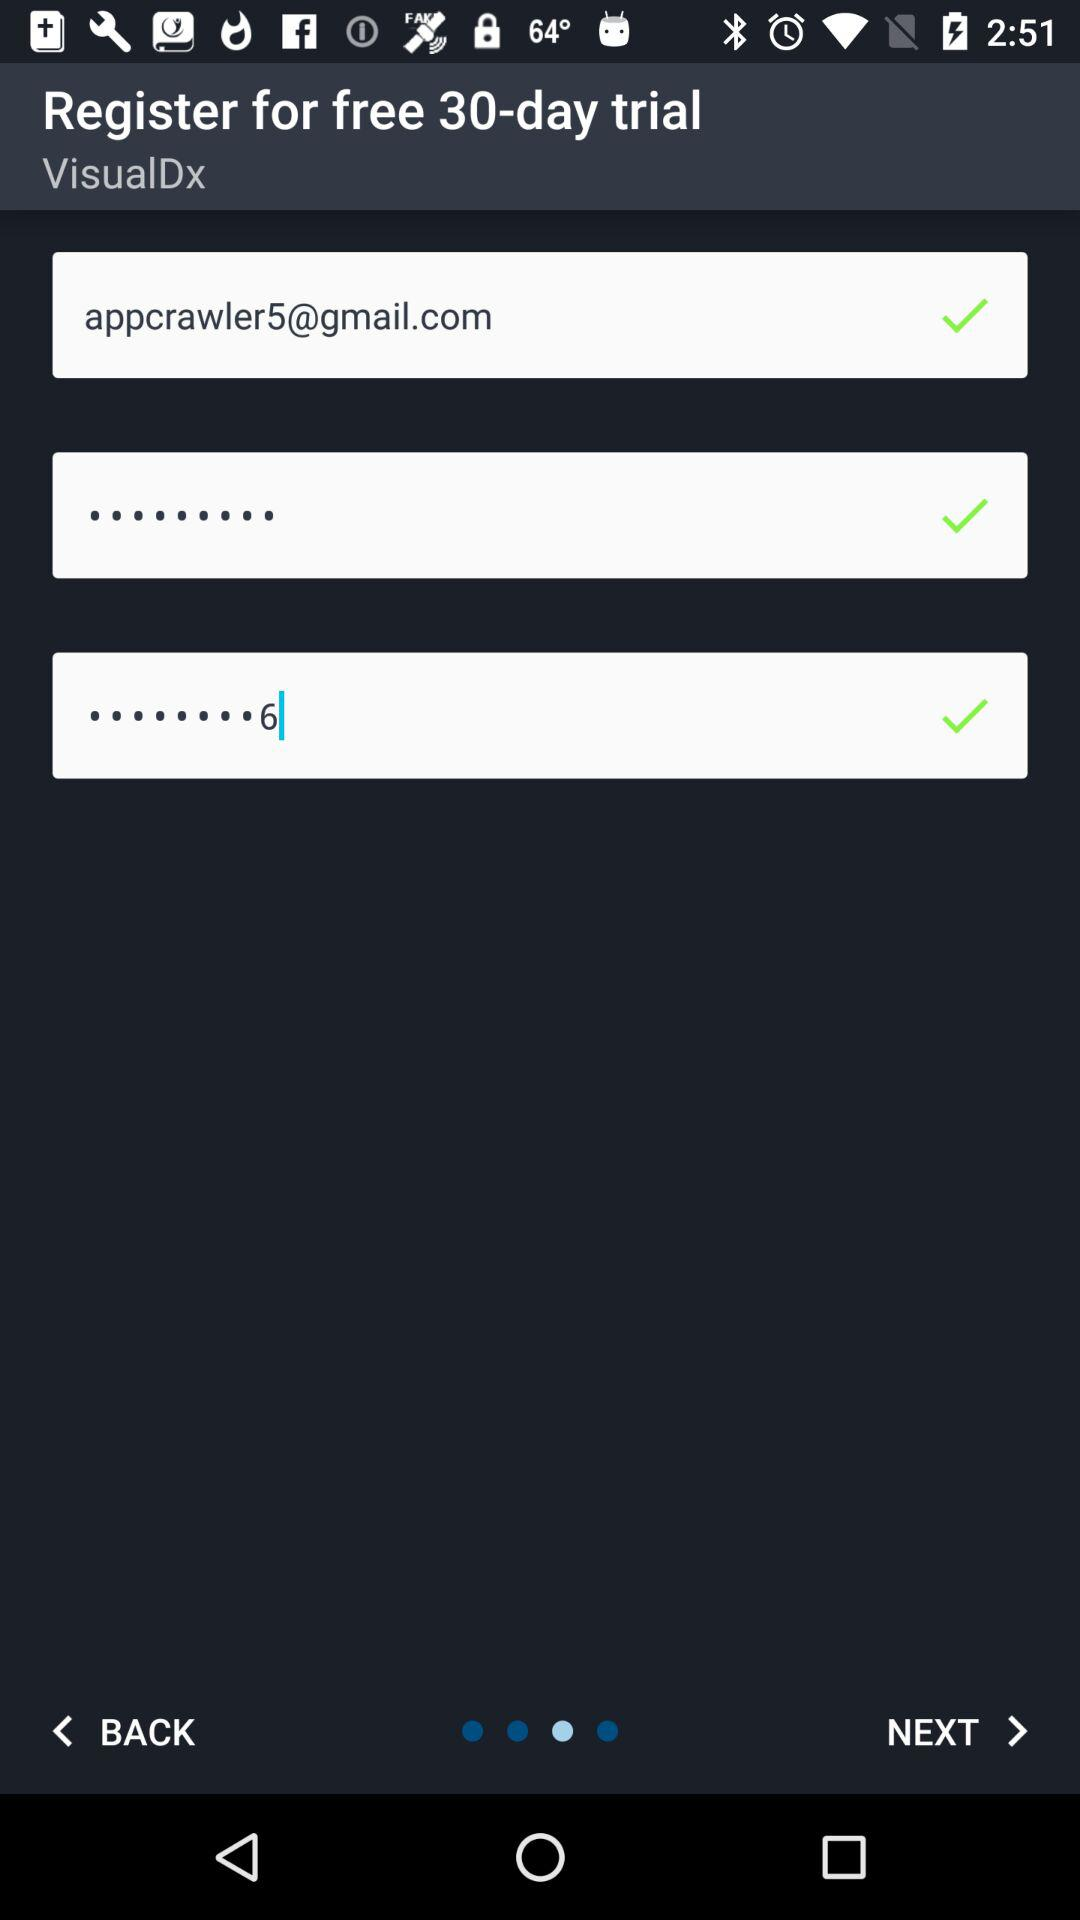How many checkmarks are there on this screen?
Answer the question using a single word or phrase. 3 